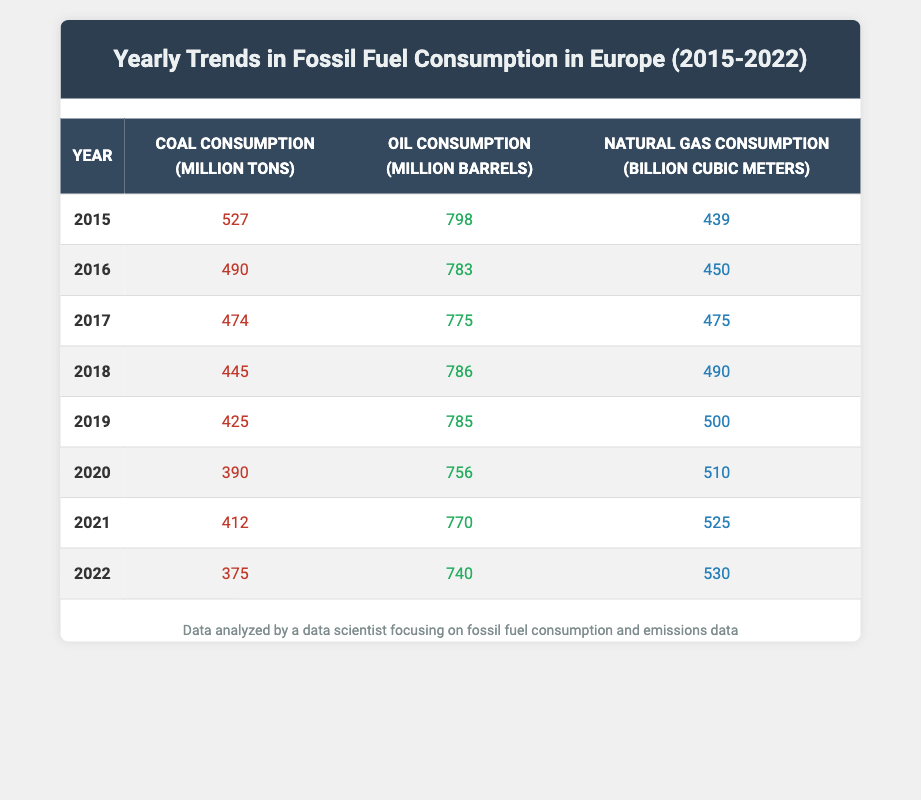What was the total coal consumption in 2020? The coal consumption in 2020 is listed as 390 million tons. Therefore, the total coal consumption for that year is directly taken from the table.
Answer: 390 million tons What is the year with the highest oil consumption? Looking at the oil consumption values, 2015 has the highest consumption figure of 798 million barrels. I can confirm this by comparing the oil consumption data across all years.
Answer: 2015 Was there an increase in natural gas consumption from 2020 to 2021? Natural gas consumption in 2020 was 510 billion cubic meters, and it rose to 525 billion cubic meters in 2021. To confirm an increase, we subtract the two values: 525 - 510 = 15, which is greater than 0, indicating an increase.
Answer: Yes What is the difference in coal consumption between 2015 and 2022? Coal consumption in 2015 was 527 million tons, and in 2022 it was 375 million tons. To find the difference: 527 - 375 = 152 million tons. This calculation shows how much less coal is consumed in 2022 compared to 2015.
Answer: 152 million tons What was the average oil consumption from 2015 to 2022? To find the average, I sum the oil consumption from each of the years: 798 + 783 + 775 + 786 + 785 + 756 + 770 + 740 = 5,763 million barrels. Then, divide this sum by the number of years (8): 5,763 / 8 = 720.375 million barrels. This value represents the average oil consumption over the eight years.
Answer: 720.375 million barrels 